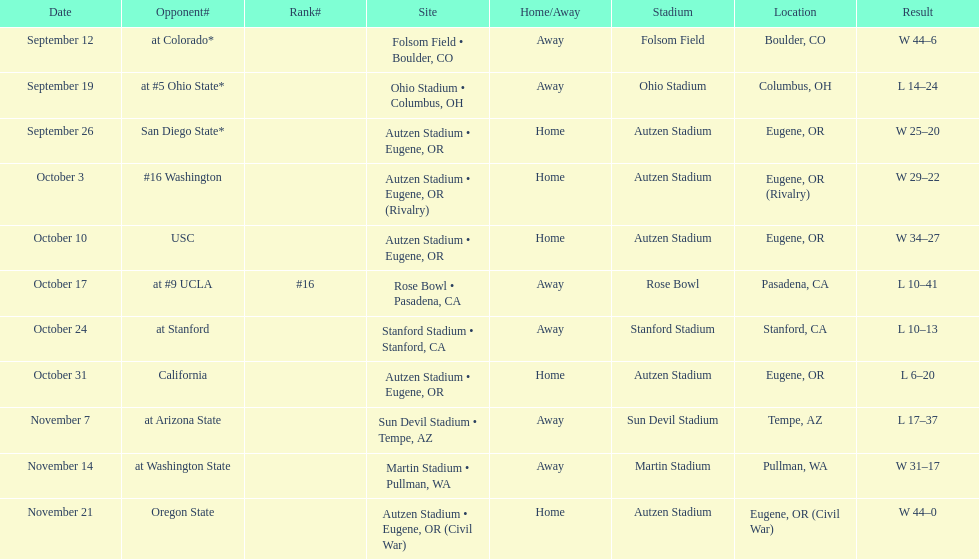How many wins are listed for the season? 6. 